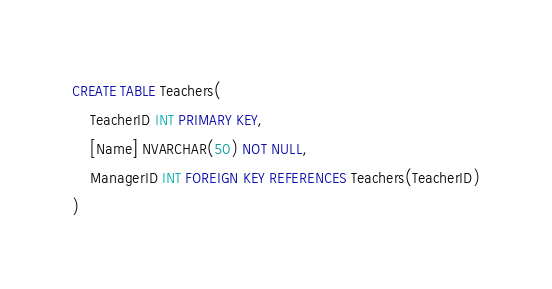Convert code to text. <code><loc_0><loc_0><loc_500><loc_500><_SQL_>CREATE TABLE Teachers(
	TeacherID INT PRIMARY KEY,
	[Name] NVARCHAR(50) NOT NULL,
	ManagerID INT FOREIGN KEY REFERENCES Teachers(TeacherID)
)</code> 